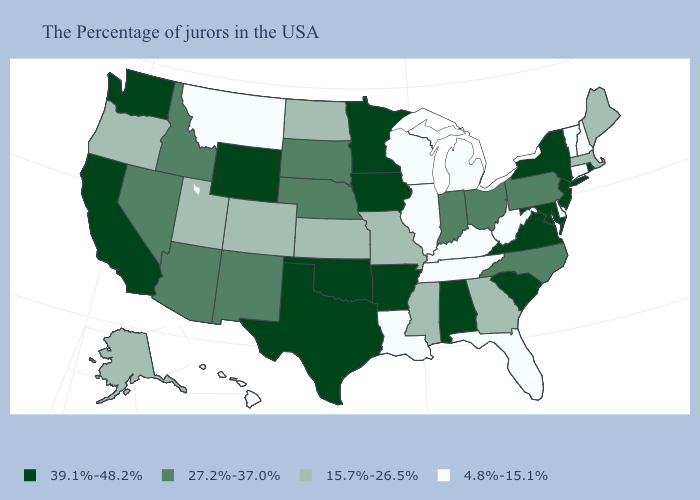Which states have the lowest value in the USA?
Quick response, please. New Hampshire, Vermont, Connecticut, Delaware, West Virginia, Florida, Michigan, Kentucky, Tennessee, Wisconsin, Illinois, Louisiana, Montana, Hawaii. Which states have the lowest value in the South?
Write a very short answer. Delaware, West Virginia, Florida, Kentucky, Tennessee, Louisiana. What is the lowest value in the Northeast?
Answer briefly. 4.8%-15.1%. Does New York have the same value as Georgia?
Keep it brief. No. Which states have the lowest value in the USA?
Write a very short answer. New Hampshire, Vermont, Connecticut, Delaware, West Virginia, Florida, Michigan, Kentucky, Tennessee, Wisconsin, Illinois, Louisiana, Montana, Hawaii. Name the states that have a value in the range 4.8%-15.1%?
Concise answer only. New Hampshire, Vermont, Connecticut, Delaware, West Virginia, Florida, Michigan, Kentucky, Tennessee, Wisconsin, Illinois, Louisiana, Montana, Hawaii. Among the states that border Connecticut , does Massachusetts have the highest value?
Short answer required. No. What is the lowest value in the USA?
Write a very short answer. 4.8%-15.1%. Which states have the highest value in the USA?
Short answer required. Rhode Island, New York, New Jersey, Maryland, Virginia, South Carolina, Alabama, Arkansas, Minnesota, Iowa, Oklahoma, Texas, Wyoming, California, Washington. Among the states that border North Carolina , which have the highest value?
Short answer required. Virginia, South Carolina. Name the states that have a value in the range 15.7%-26.5%?
Keep it brief. Maine, Massachusetts, Georgia, Mississippi, Missouri, Kansas, North Dakota, Colorado, Utah, Oregon, Alaska. What is the value of Hawaii?
Keep it brief. 4.8%-15.1%. Does Washington have the same value as Rhode Island?
Short answer required. Yes. Name the states that have a value in the range 4.8%-15.1%?
Be succinct. New Hampshire, Vermont, Connecticut, Delaware, West Virginia, Florida, Michigan, Kentucky, Tennessee, Wisconsin, Illinois, Louisiana, Montana, Hawaii. What is the lowest value in the West?
Concise answer only. 4.8%-15.1%. 